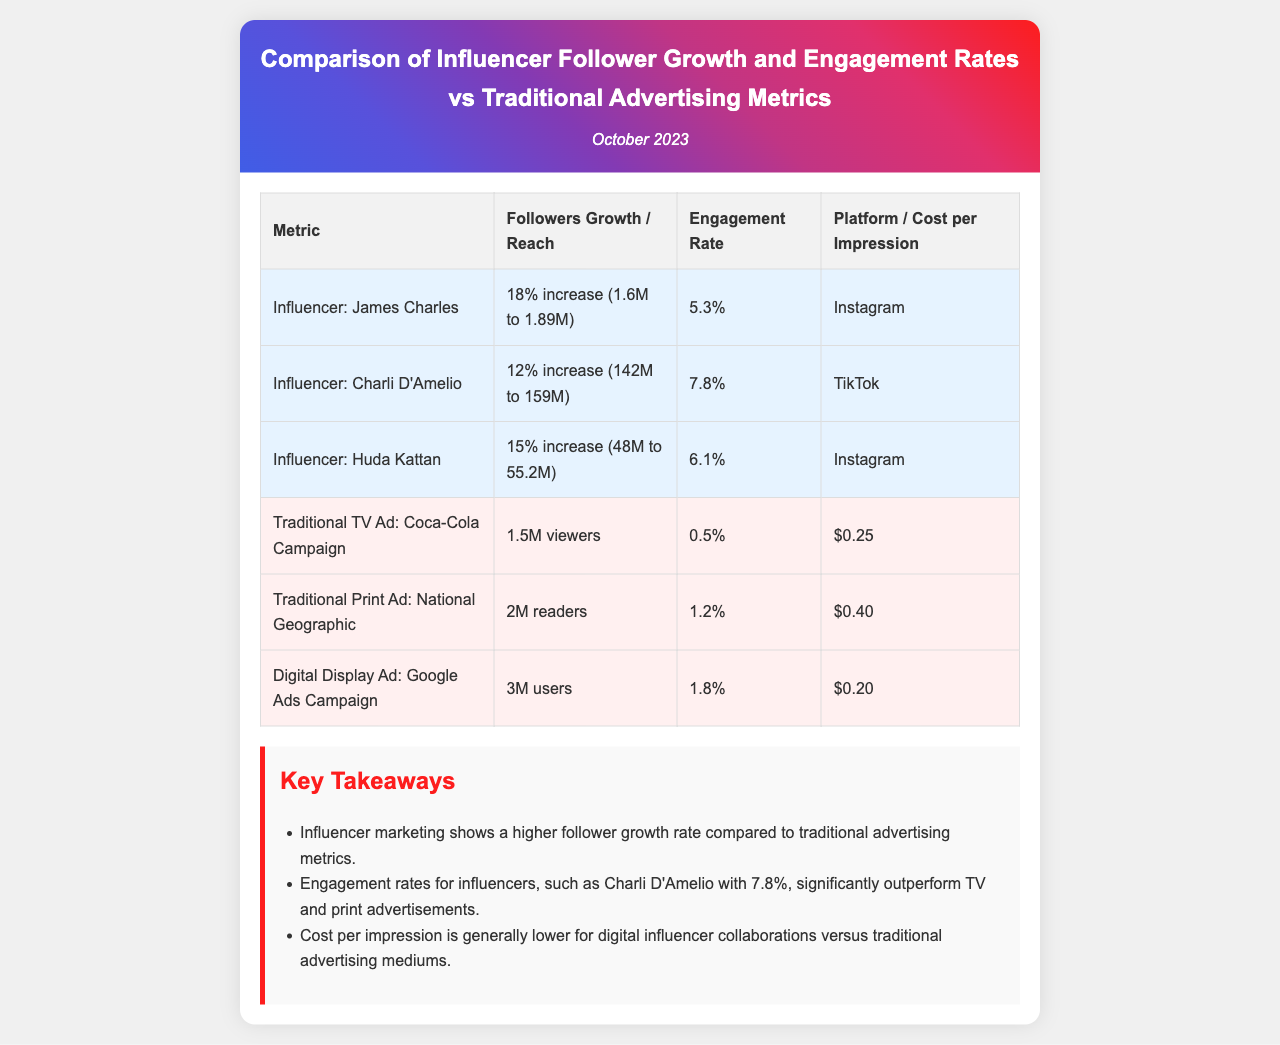What is the engagement rate for Charli D'Amelio? The engagement rate for Charli D'Amelio is stated in the document under her row in the engagement rate column as 7.8%.
Answer: 7.8% What is the follower growth for Huda Kattan? The follower growth for Huda Kattan is shown as a 15% increase from 48M to 55.2M in the follower growth column.
Answer: 15% increase How many viewers did the Coca-Cola traditional TV ad reach? The number of viewers for the Coca-Cola traditional TV ad is specified as 1.5M in the viewers column.
Answer: 1.5M Which platform had the highest engagement rate among influencers? The engagement rates for influencers are compared, revealing that Charli D'Amelio has the highest at 7.8% in the respective column.
Answer: TikTok What is the cost per impression for the Digital Display Ad campaign? The cost per impression for the Digital Display Ad campaign is listed as $0.20 in the cost per impression column.
Answer: $0.20 Which influencer experienced the highest increase in followers? The document indicates that Charli D'Amelio experienced the highest increase in followers with a 12% increase from 142M to 159M.
Answer: Charli D'Amelio What is the engagement rate for traditional print ads according to the document? The engagement rate for traditional print ads is described as 1.2% in the engagement rate column alongside National Geographic.
Answer: 1.2% What key takeaway highlights cost per impression in influencer marketing? One of the key takeaways specifically mentions that cost per impression is generally lower for digital influencer collaborations compared to traditional advertising.
Answer: Lower for digital influencer collaborations 